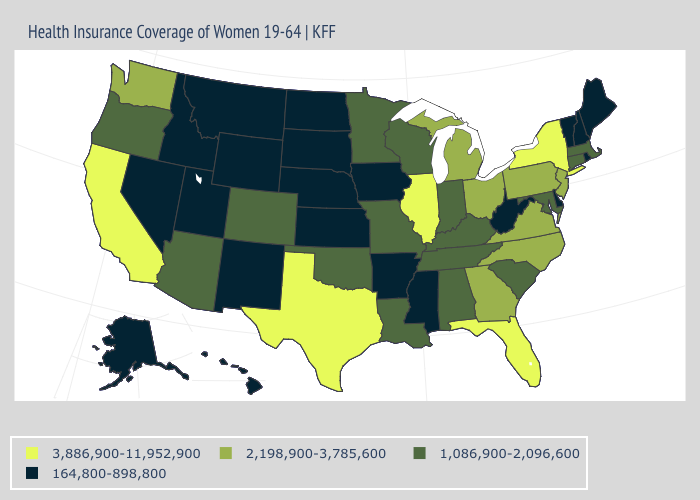Name the states that have a value in the range 1,086,900-2,096,600?
Keep it brief. Alabama, Arizona, Colorado, Connecticut, Indiana, Kentucky, Louisiana, Maryland, Massachusetts, Minnesota, Missouri, Oklahoma, Oregon, South Carolina, Tennessee, Wisconsin. Does Idaho have the same value as New York?
Short answer required. No. What is the value of Vermont?
Write a very short answer. 164,800-898,800. What is the highest value in the USA?
Give a very brief answer. 3,886,900-11,952,900. What is the highest value in states that border Florida?
Be succinct. 2,198,900-3,785,600. What is the lowest value in the Northeast?
Give a very brief answer. 164,800-898,800. Among the states that border Massachusetts , does Rhode Island have the lowest value?
Be succinct. Yes. Among the states that border Utah , which have the highest value?
Short answer required. Arizona, Colorado. Among the states that border Wyoming , does Colorado have the highest value?
Keep it brief. Yes. Does New Jersey have the highest value in the Northeast?
Write a very short answer. No. Which states hav the highest value in the West?
Write a very short answer. California. Does West Virginia have the lowest value in the South?
Concise answer only. Yes. What is the value of Alabama?
Short answer required. 1,086,900-2,096,600. Among the states that border Maine , which have the lowest value?
Be succinct. New Hampshire. 